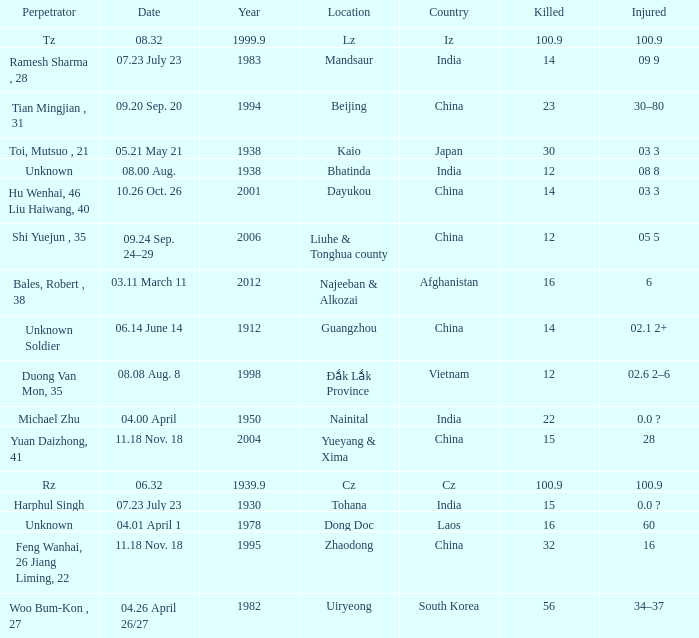What is Injured, when Country is "Afghanistan"? 6.0. 